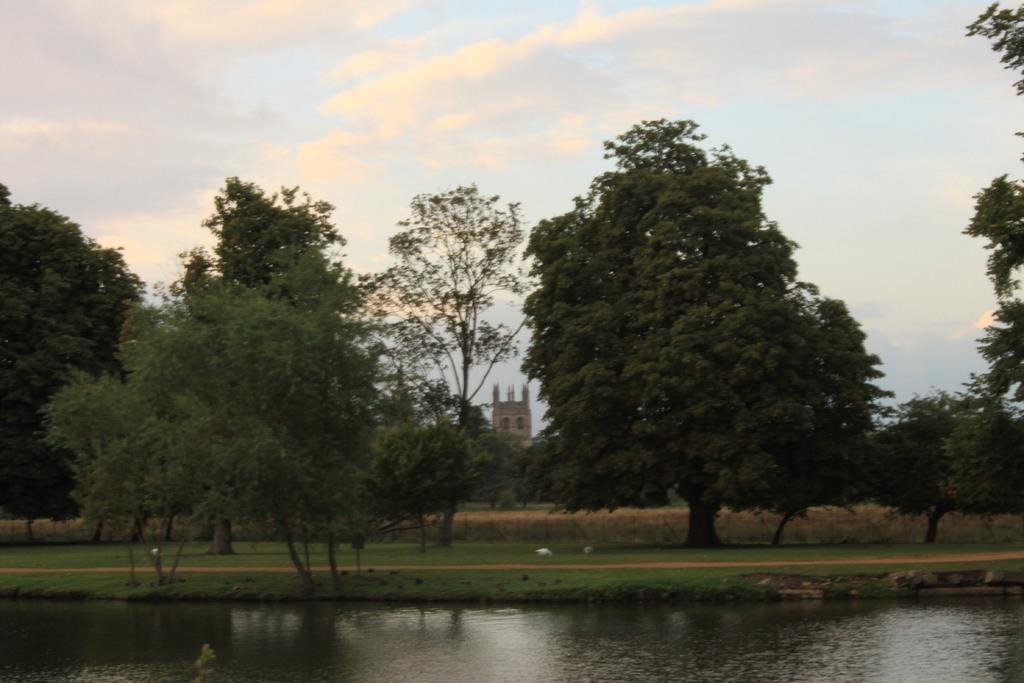How would you summarize this image in a sentence or two? In this image we can see some trees, grass, water and a building, in the background, we can see the sky with clouds. 